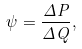<formula> <loc_0><loc_0><loc_500><loc_500>\psi = \frac { \Delta P } { \Delta Q } ,</formula> 